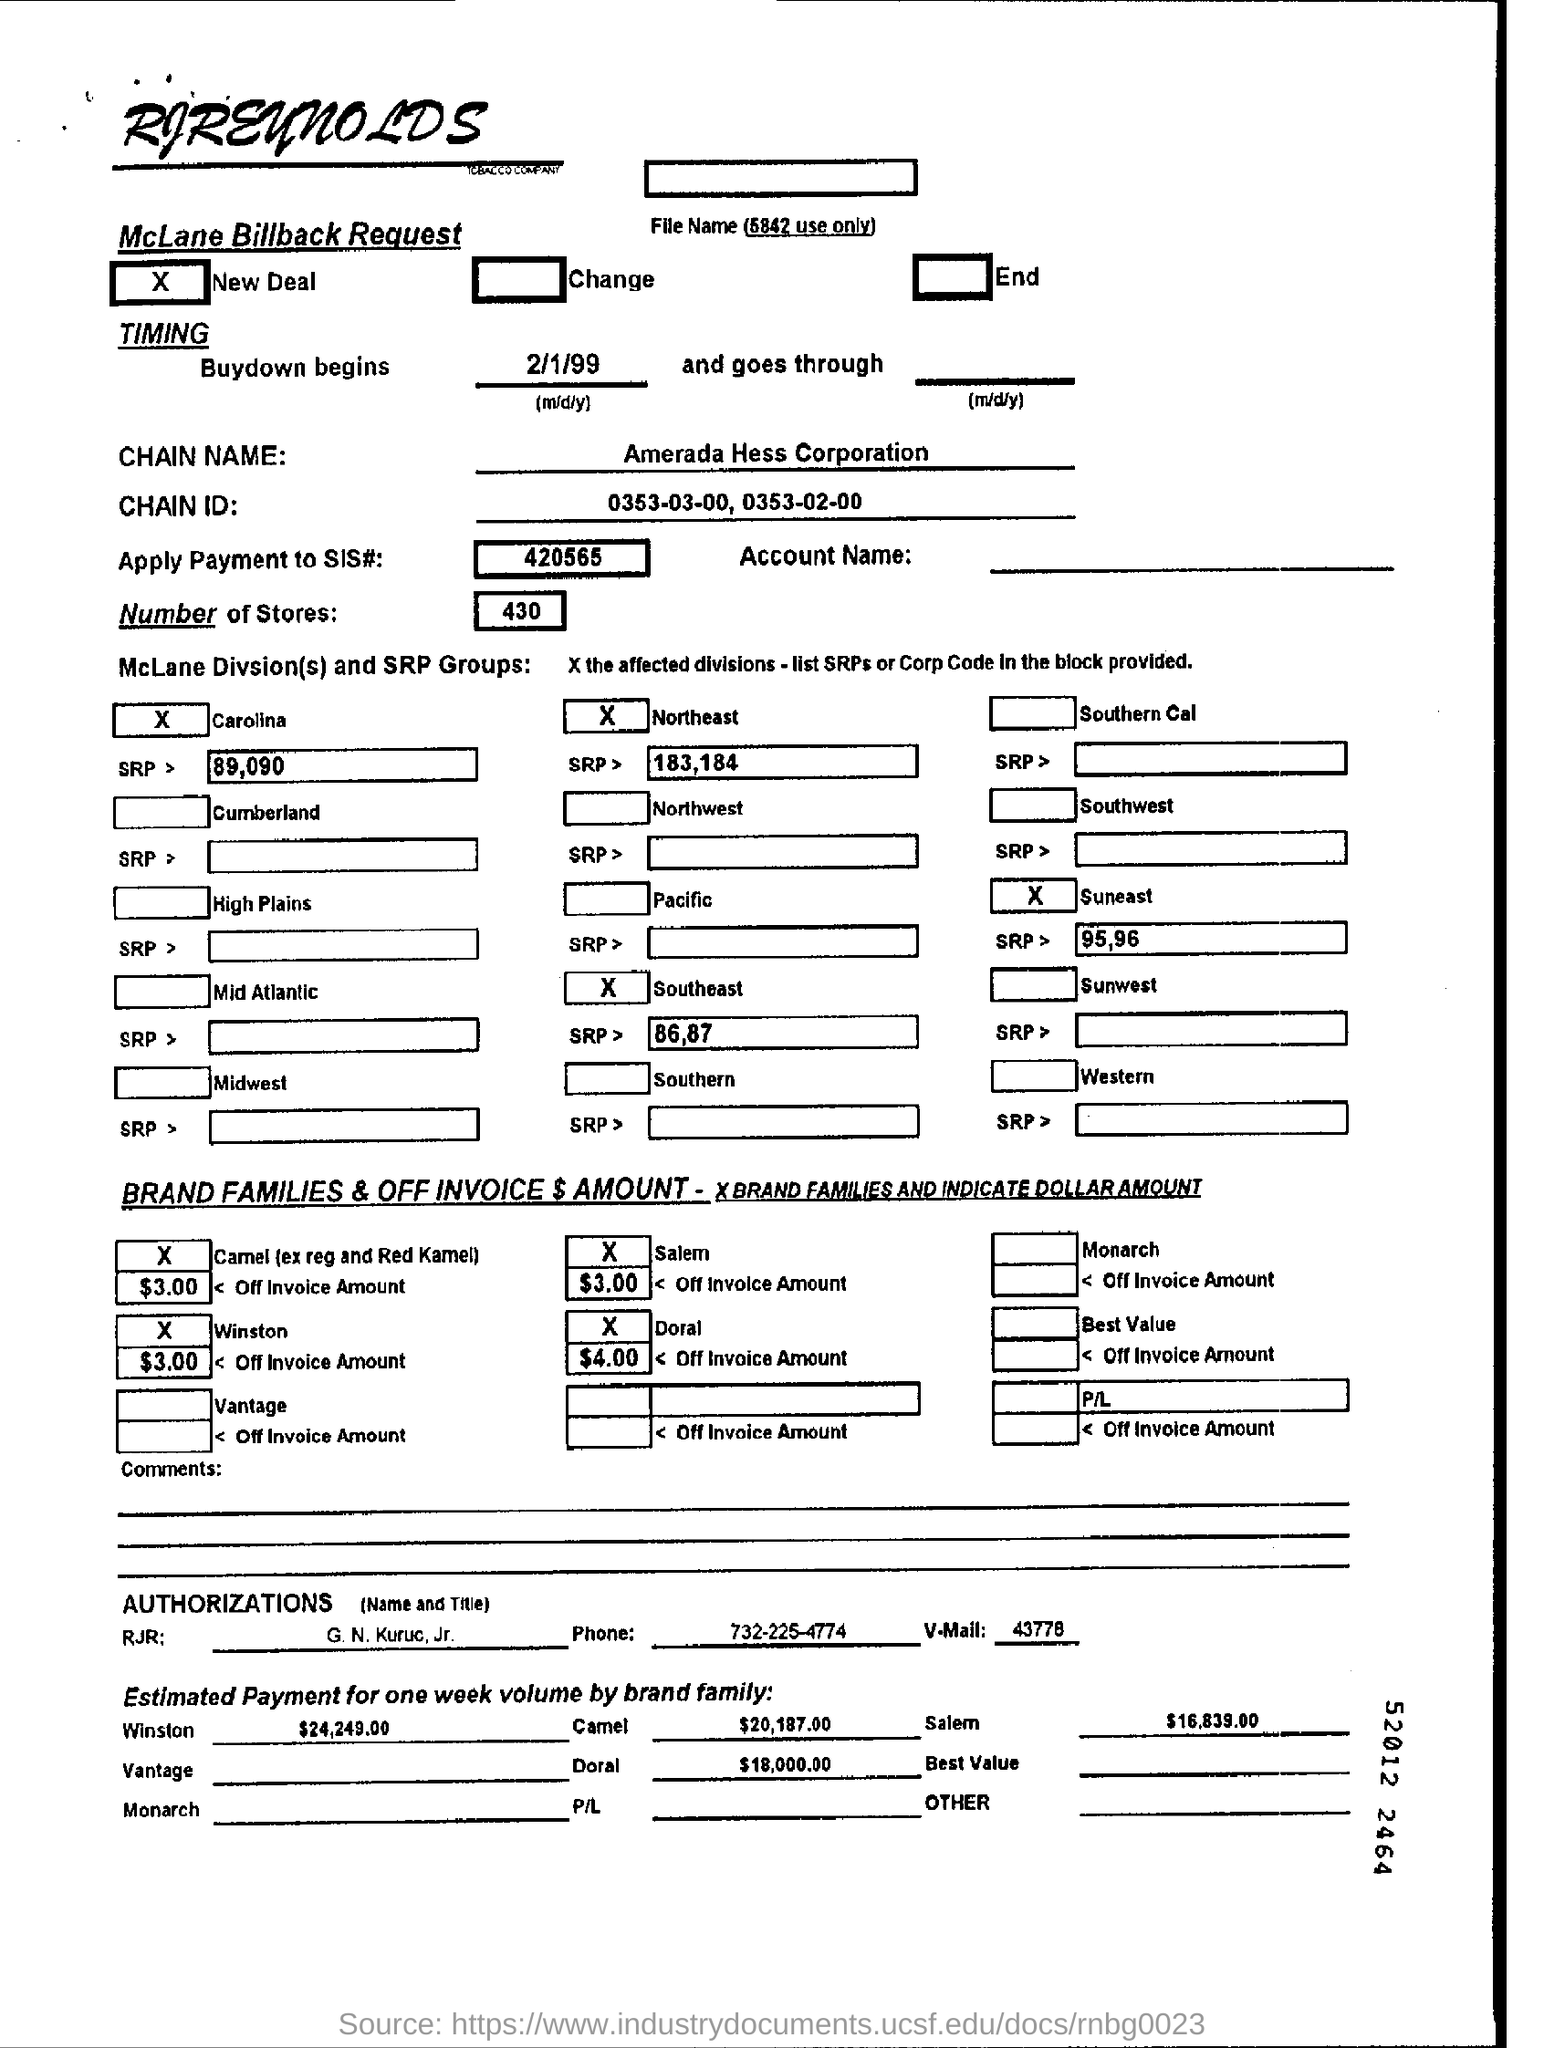Outline some significant characteristics in this image. I am referring to the company name 'Amerada Hess Corporation.' The phone number mentioned is 732-225-4774. The chain ID mentioned is 0353-03-00, 0353-02-00, and so on. The date for when the buy-down begins is February 1, 1999. There are 430 stores mentioned. 